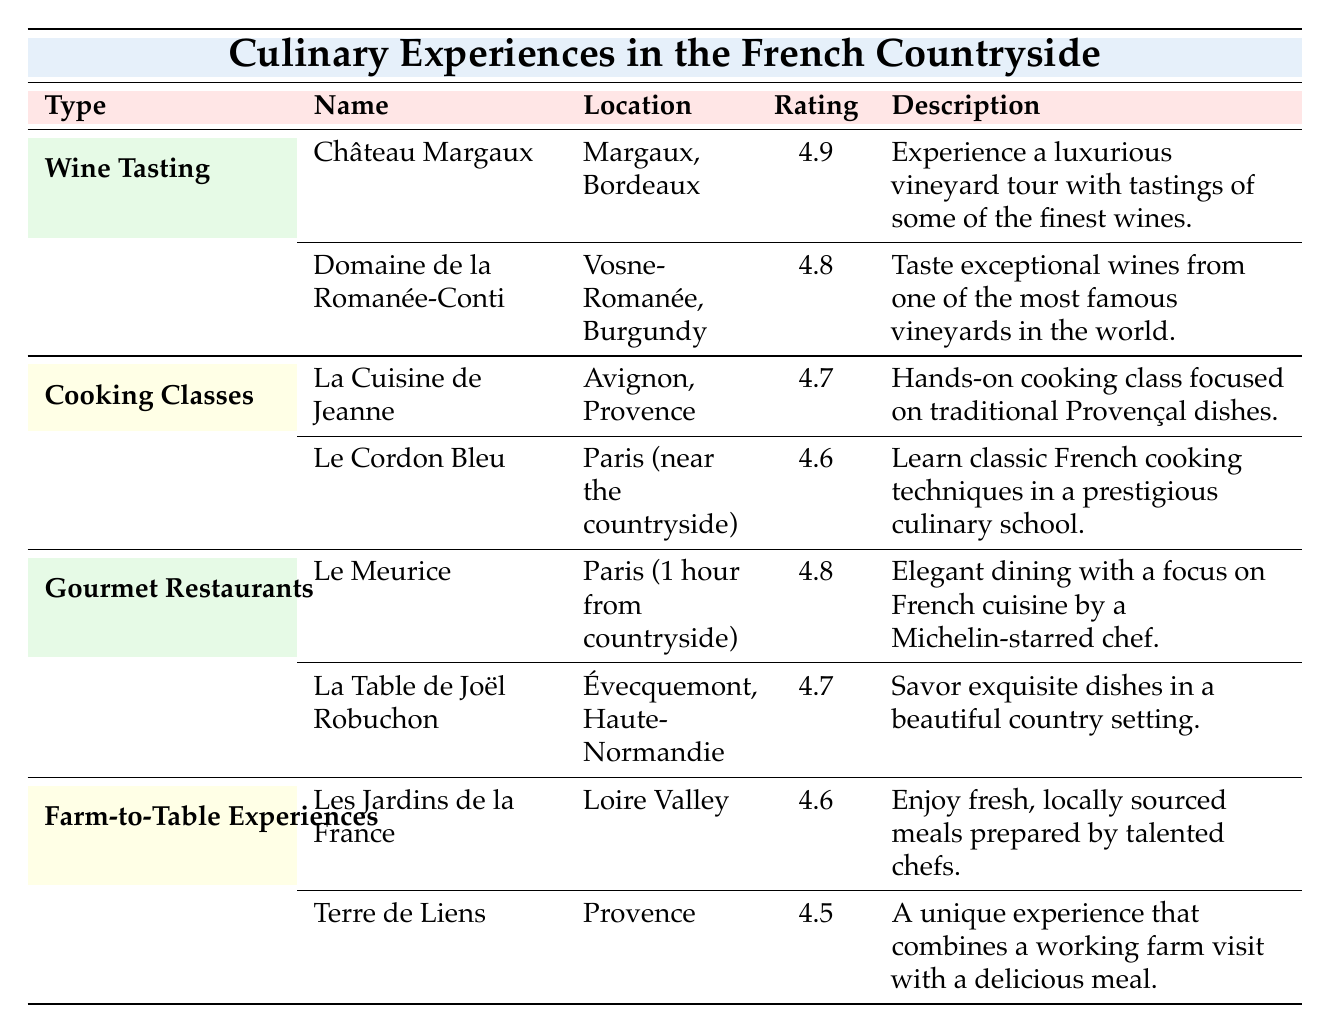What are the names of the two wine tasting experiences? The table lists two wine tasting experiences: Château Margaux and Domaine de la Romanée-Conti.
Answer: Château Margaux, Domaine de la Romanée-Conti Which cooking class has the highest rating? By comparing the ratings in the cooking classes section, La Cuisine de Jeanne has a rating of 4.7, while Le Cordon Bleu has a rating of 4.6. Since 4.7 is higher, La Cuisine de Jeanne has the highest rating.
Answer: La Cuisine de Jeanne True or False: La Table de Joël Robuchon is located in Paris. The location of La Table de Joël Robuchon is noted as Évecquemont, Haute-Normandie, which is not in Paris. Therefore, the statement is false.
Answer: False What is the average rating for gourmet restaurants? The ratings for the two gourmet restaurants are 4.8 for Le Meurice and 4.7 for La Table de Joël Robuchon. Adding these ratings gives 4.8 + 4.7 = 9.5, and dividing by 2, the average is 9.5 / 2 = 4.75.
Answer: 4.75 Which culinary experience has the description of "hands-on cooking class focused on traditional Provençal dishes"? Referring to the table, the description matches La Cuisine de Jeanne, which is a cooking class in Avignon, Provence.
Answer: La Cuisine de Jeanne True or False: There is a wine tasting experience in the Loire Valley. The table does not list any wine tasting experiences in the Loire Valley; Château Margaux and Domaine de la Romanée-Conti are located in Margaux, Bordeaux and Vosne-Romanée, Burgundy respectively. Therefore, the statement is false.
Answer: False Which culinary experience located in Provence has the lowest rating? The two experiences in Provence are La Cuisine de Jeanne with a rating of 4.7 and Terre de Liens with a rating of 4.5. Among these, Terre de Liens has the lower rating at 4.5.
Answer: Terre de Liens What is the description of the experience with the highest rating overall? The experience with the highest rating is Château Margaux with a rating of 4.9. Its description states that it offers a luxurious vineyard tour with tastings of some of the finest wines.
Answer: Experience a luxurious vineyard tour with tastings of some of the finest wines 